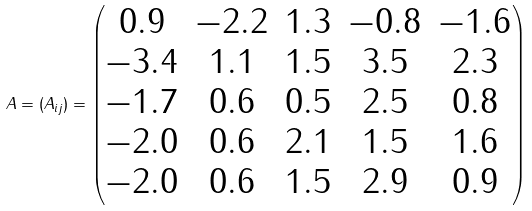Convert formula to latex. <formula><loc_0><loc_0><loc_500><loc_500>A = ( A _ { i j } ) = \begin{pmatrix} 0 . 9 & - 2 . 2 & 1 . 3 & - 0 . 8 & - 1 . 6 \\ - 3 . 4 & 1 . 1 & 1 . 5 & 3 . 5 & 2 . 3 \\ - 1 . 7 & 0 . 6 & 0 . 5 & 2 . 5 & 0 . 8 \\ - 2 . 0 & 0 . 6 & 2 . 1 & 1 . 5 & 1 . 6 \\ - 2 . 0 & 0 . 6 & 1 . 5 & 2 . 9 & 0 . 9 \end{pmatrix}</formula> 